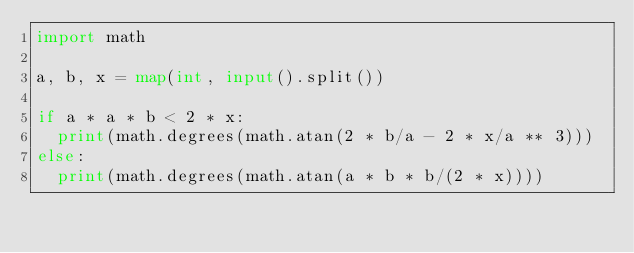Convert code to text. <code><loc_0><loc_0><loc_500><loc_500><_Python_>import math

a, b, x = map(int, input().split())

if a * a * b < 2 * x:
  print(math.degrees(math.atan(2 * b/a - 2 * x/a ** 3)))
else:
  print(math.degrees(math.atan(a * b * b/(2 * x))))</code> 